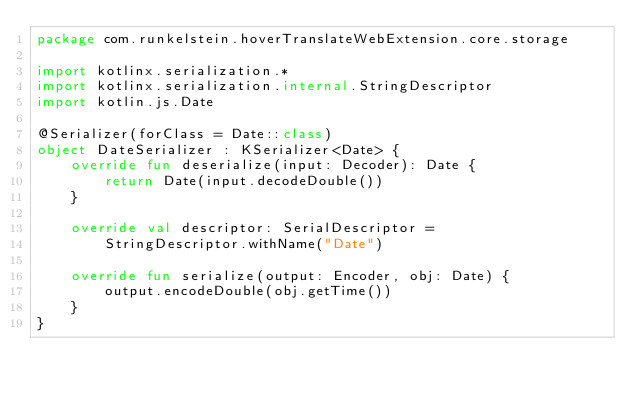Convert code to text. <code><loc_0><loc_0><loc_500><loc_500><_Kotlin_>package com.runkelstein.hoverTranslateWebExtension.core.storage

import kotlinx.serialization.*
import kotlinx.serialization.internal.StringDescriptor
import kotlin.js.Date

@Serializer(forClass = Date::class)
object DateSerializer : KSerializer<Date> {
    override fun deserialize(input: Decoder): Date {
        return Date(input.decodeDouble())
    }

    override val descriptor: SerialDescriptor =
        StringDescriptor.withName("Date")

    override fun serialize(output: Encoder, obj: Date) {
        output.encodeDouble(obj.getTime())
    }
}</code> 